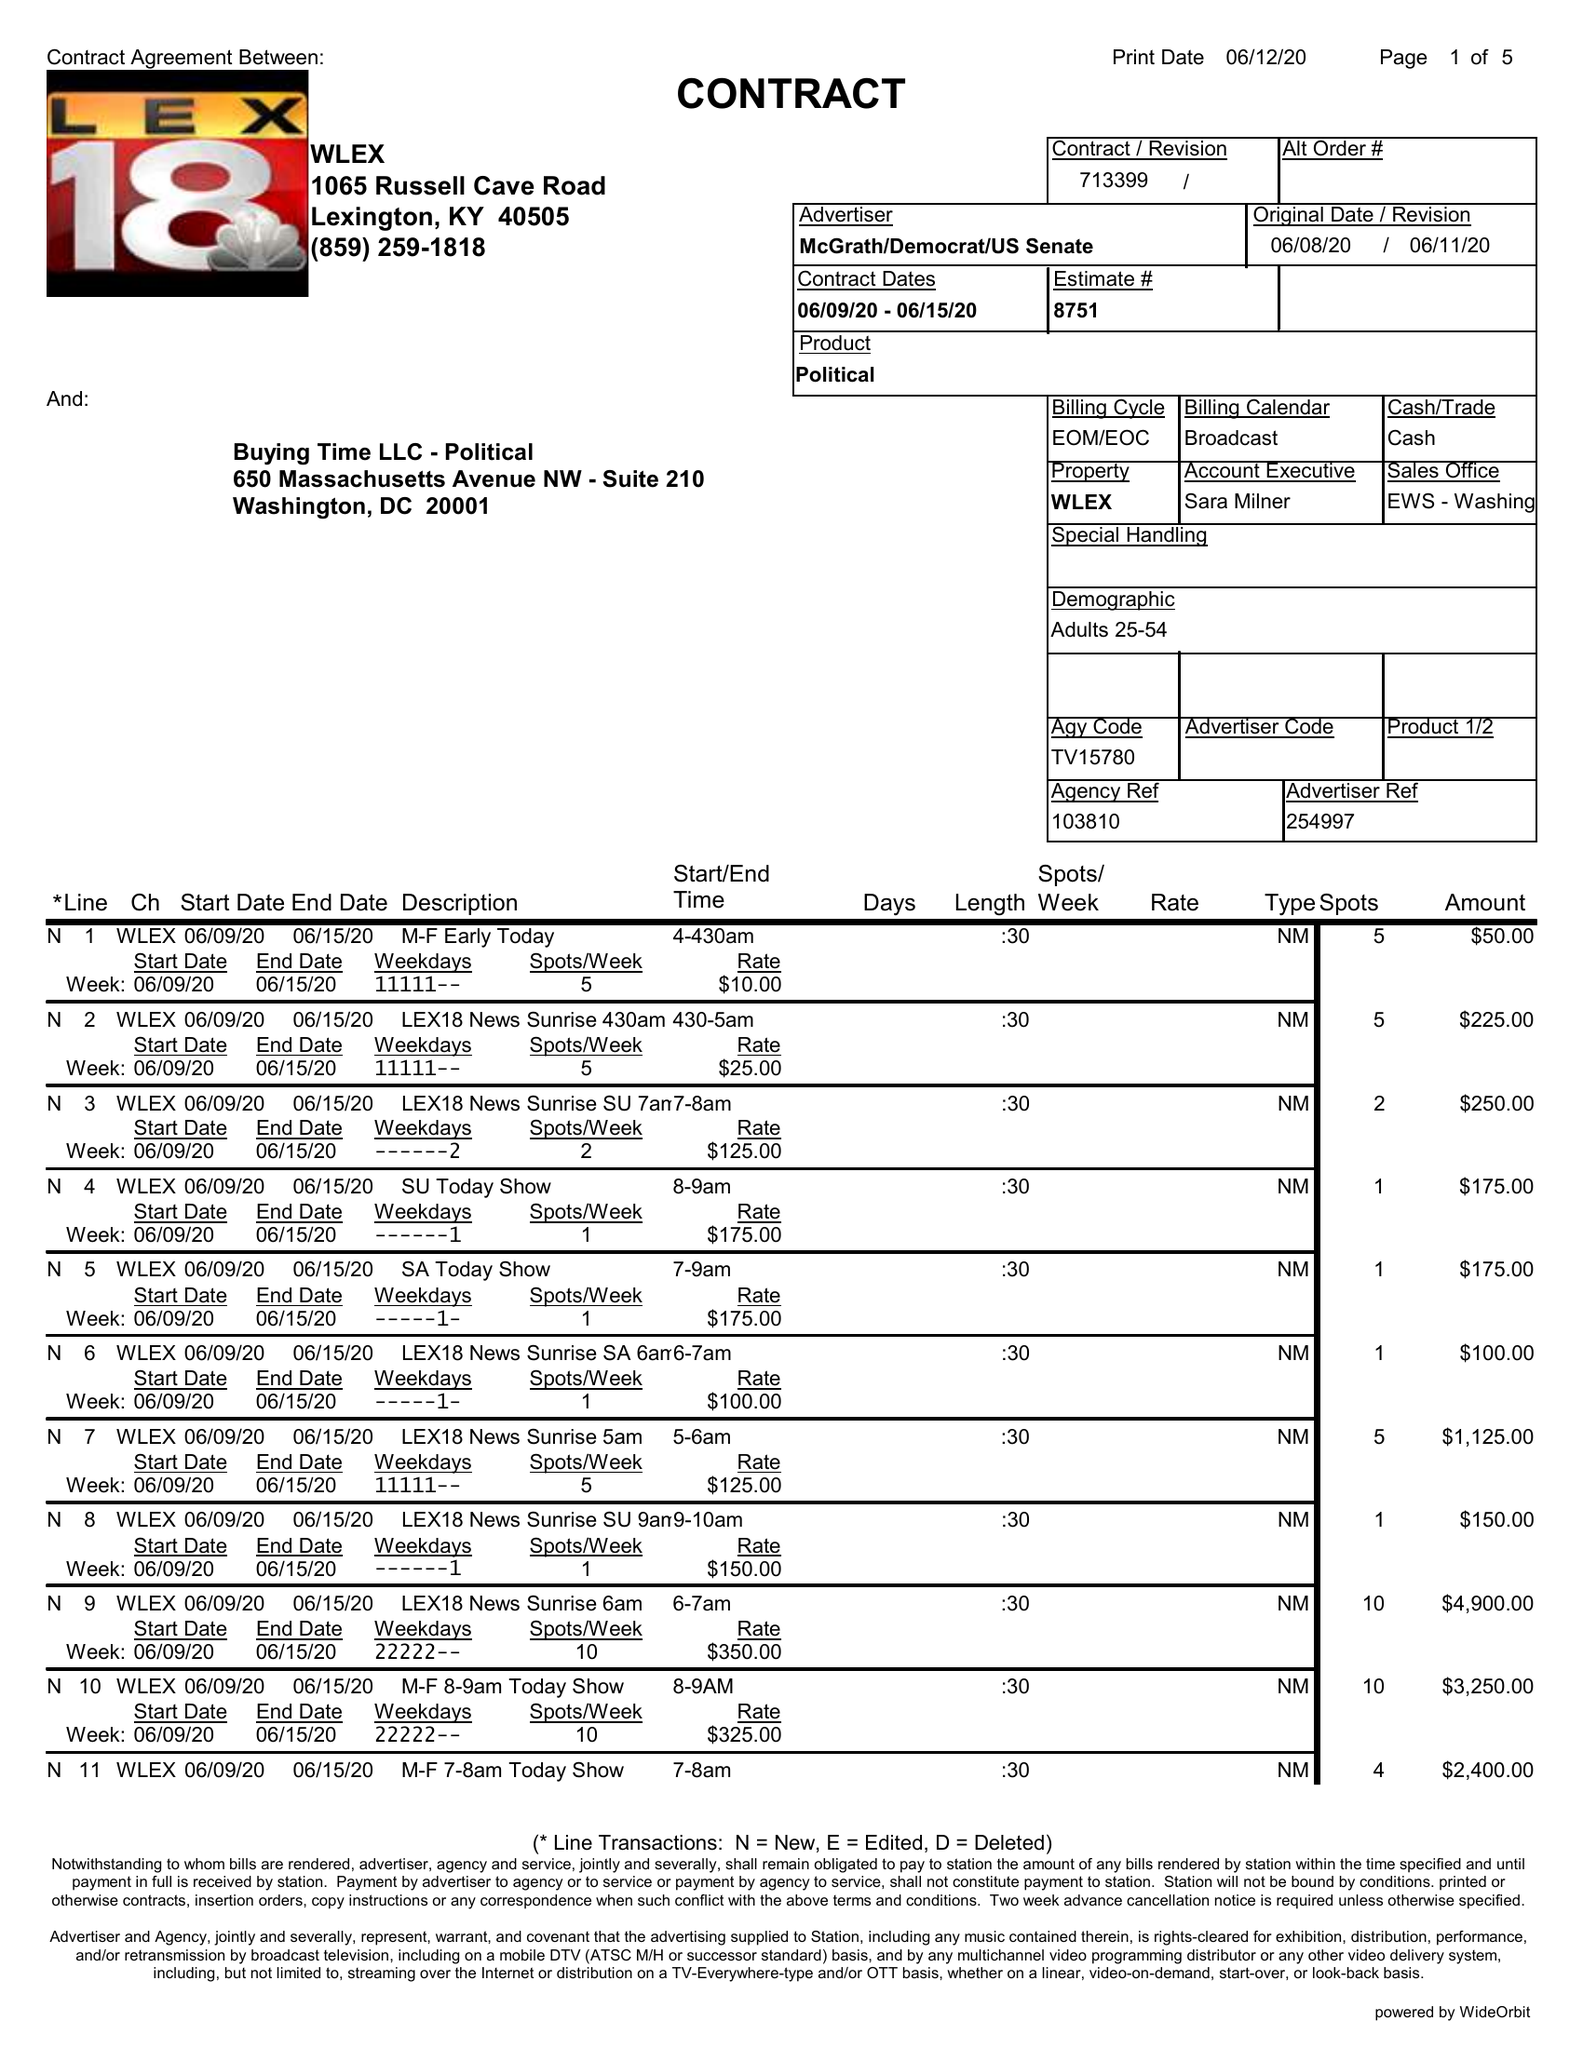What is the value for the flight_from?
Answer the question using a single word or phrase. 06/09/20 